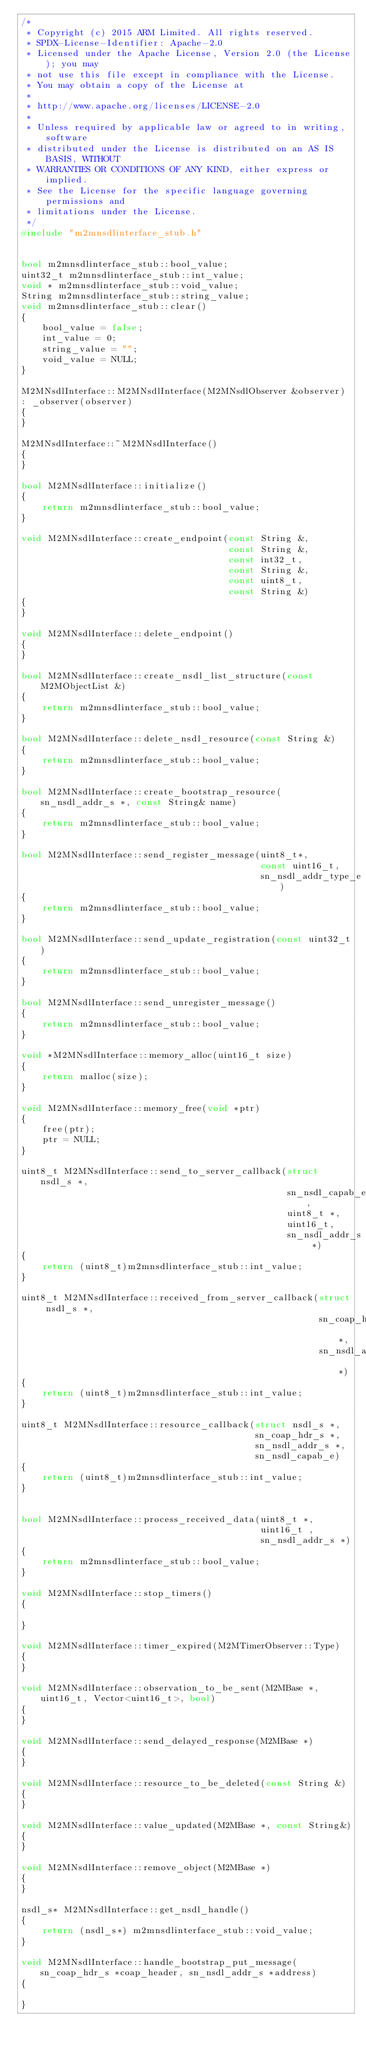<code> <loc_0><loc_0><loc_500><loc_500><_C++_>/*
 * Copyright (c) 2015 ARM Limited. All rights reserved.
 * SPDX-License-Identifier: Apache-2.0
 * Licensed under the Apache License, Version 2.0 (the License); you may
 * not use this file except in compliance with the License.
 * You may obtain a copy of the License at
 *
 * http://www.apache.org/licenses/LICENSE-2.0
 *
 * Unless required by applicable law or agreed to in writing, software
 * distributed under the License is distributed on an AS IS BASIS, WITHOUT
 * WARRANTIES OR CONDITIONS OF ANY KIND, either express or implied.
 * See the License for the specific language governing permissions and
 * limitations under the License.
 */
#include "m2mnsdlinterface_stub.h"


bool m2mnsdlinterface_stub::bool_value;
uint32_t m2mnsdlinterface_stub::int_value;
void * m2mnsdlinterface_stub::void_value;
String m2mnsdlinterface_stub::string_value;
void m2mnsdlinterface_stub::clear()
{
    bool_value = false;
    int_value = 0;
    string_value = "";
    void_value = NULL;
}

M2MNsdlInterface::M2MNsdlInterface(M2MNsdlObserver &observer)
: _observer(observer)
{
}

M2MNsdlInterface::~M2MNsdlInterface()
{
}

bool M2MNsdlInterface::initialize()
{
    return m2mnsdlinterface_stub::bool_value;
}

void M2MNsdlInterface::create_endpoint(const String &,
                                       const String &,
                                       const int32_t,
                                       const String &,
                                       const uint8_t,
                                       const String &)
{
}

void M2MNsdlInterface::delete_endpoint()
{
}

bool M2MNsdlInterface::create_nsdl_list_structure(const M2MObjectList &)
{
    return m2mnsdlinterface_stub::bool_value;
}

bool M2MNsdlInterface::delete_nsdl_resource(const String &)
{
    return m2mnsdlinterface_stub::bool_value;
}

bool M2MNsdlInterface::create_bootstrap_resource(sn_nsdl_addr_s *, const String& name)
{
    return m2mnsdlinterface_stub::bool_value;
}

bool M2MNsdlInterface::send_register_message(uint8_t*,
                                             const uint16_t,
                                             sn_nsdl_addr_type_e)
{
    return m2mnsdlinterface_stub::bool_value;
}

bool M2MNsdlInterface::send_update_registration(const uint32_t)
{
    return m2mnsdlinterface_stub::bool_value;
}

bool M2MNsdlInterface::send_unregister_message()
{
    return m2mnsdlinterface_stub::bool_value;
}

void *M2MNsdlInterface::memory_alloc(uint16_t size)
{
    return malloc(size);
}

void M2MNsdlInterface::memory_free(void *ptr)
{
    free(ptr);
    ptr = NULL;
}

uint8_t M2MNsdlInterface::send_to_server_callback(struct nsdl_s *,
                                                  sn_nsdl_capab_e,
                                                  uint8_t *,
                                                  uint16_t,
                                                  sn_nsdl_addr_s *)
{
    return (uint8_t)m2mnsdlinterface_stub::int_value;
}

uint8_t M2MNsdlInterface::received_from_server_callback(struct nsdl_s *,
                                                        sn_coap_hdr_s *,
                                                        sn_nsdl_addr_s *)
{
    return (uint8_t)m2mnsdlinterface_stub::int_value;
}

uint8_t M2MNsdlInterface::resource_callback(struct nsdl_s *,
                                            sn_coap_hdr_s *,
                                            sn_nsdl_addr_s *,
                                            sn_nsdl_capab_e)
{
    return (uint8_t)m2mnsdlinterface_stub::int_value;
}


bool M2MNsdlInterface::process_received_data(uint8_t *,
                                             uint16_t ,
                                             sn_nsdl_addr_s *)
{
    return m2mnsdlinterface_stub::bool_value;
}

void M2MNsdlInterface::stop_timers()
{

}

void M2MNsdlInterface::timer_expired(M2MTimerObserver::Type)
{
}

void M2MNsdlInterface::observation_to_be_sent(M2MBase *, uint16_t, Vector<uint16_t>, bool)
{
}

void M2MNsdlInterface::send_delayed_response(M2MBase *)
{
}

void M2MNsdlInterface::resource_to_be_deleted(const String &)
{
}

void M2MNsdlInterface::value_updated(M2MBase *, const String&)
{
}

void M2MNsdlInterface::remove_object(M2MBase *)
{
}

nsdl_s* M2MNsdlInterface::get_nsdl_handle()
{
    return (nsdl_s*) m2mnsdlinterface_stub::void_value;
}

void M2MNsdlInterface::handle_bootstrap_put_message(sn_coap_hdr_s *coap_header, sn_nsdl_addr_s *address)
{

}
</code> 